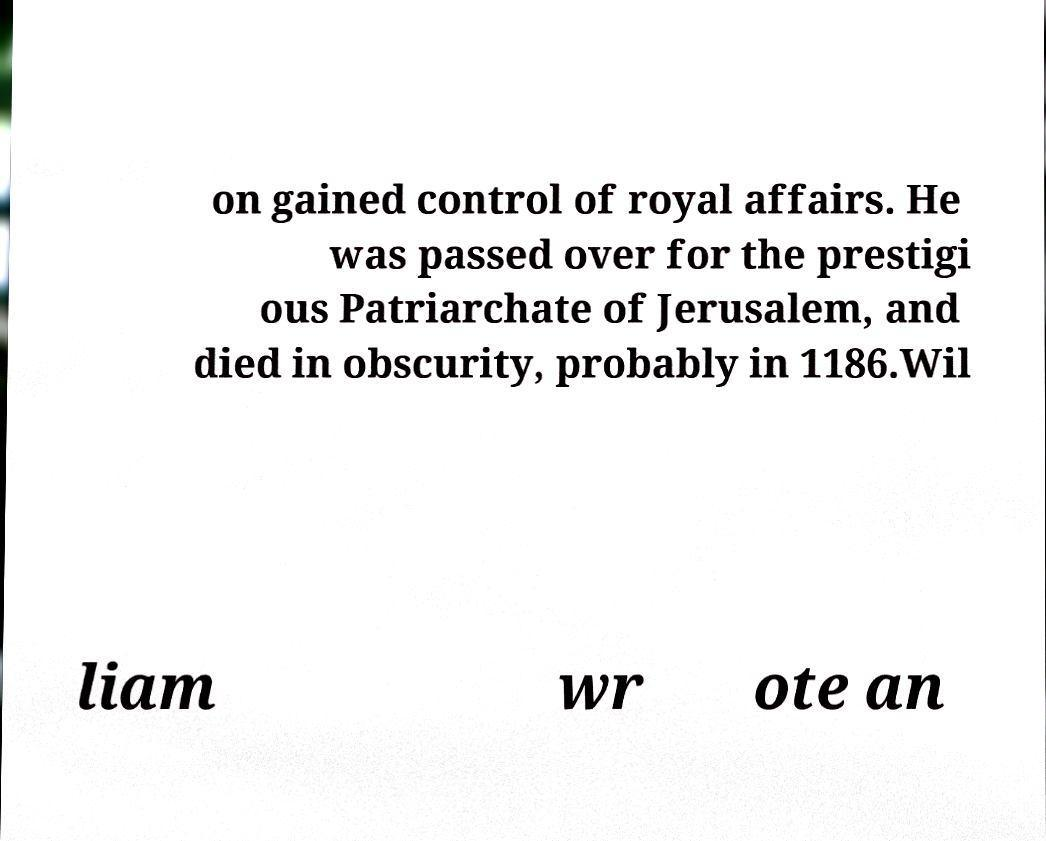There's text embedded in this image that I need extracted. Can you transcribe it verbatim? on gained control of royal affairs. He was passed over for the prestigi ous Patriarchate of Jerusalem, and died in obscurity, probably in 1186.Wil liam wr ote an 